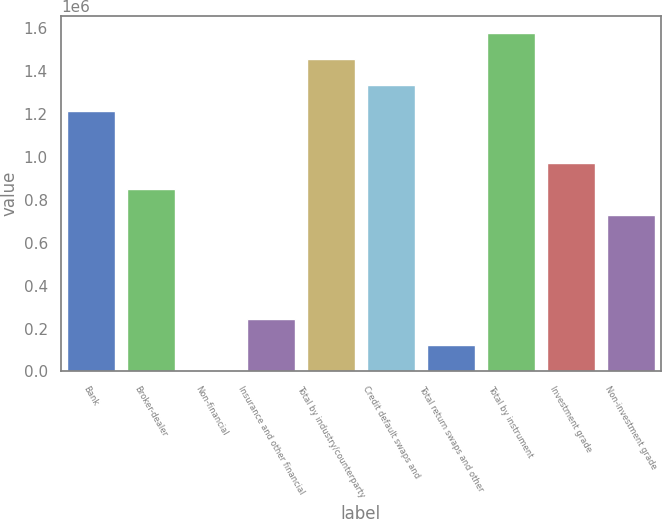Convert chart. <chart><loc_0><loc_0><loc_500><loc_500><bar_chart><fcel>Bank<fcel>Broker-dealer<fcel>Non-financial<fcel>Insurance and other financial<fcel>Total by industry/counterparty<fcel>Credit default swaps and<fcel>Total return swaps and other<fcel>Total by instrument<fcel>Investment grade<fcel>Non-investment grade<nl><fcel>1.21405e+06<fcel>850024<fcel>623<fcel>243309<fcel>1.45674e+06<fcel>1.3354e+06<fcel>121966<fcel>1.57808e+06<fcel>971367<fcel>728681<nl></chart> 